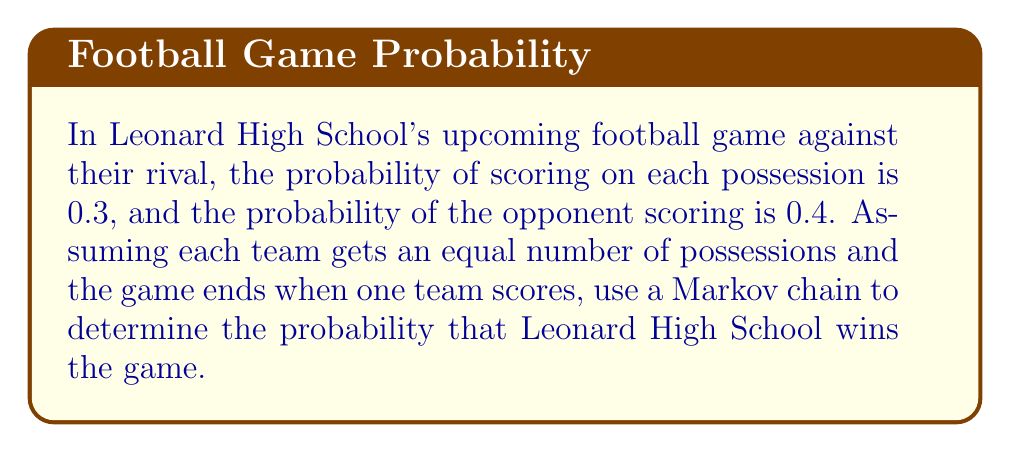Help me with this question. Let's approach this step-by-step using a Markov chain:

1) Define the states:
   State 0: Neither team has scored
   State 1: Leonard High School has scored (win)
   State 2: Opponent has scored (loss)

2) Create the transition matrix P:
   $$P = \begin{bmatrix}
   0.3 & 0.3 & 0.4 \\
   0 & 1 & 0 \\
   0 & 0 & 1
   \end{bmatrix}$$

3) States 1 and 2 are absorbing states. We want to find the probability of reaching state 1 before state 2.

4) Let $f_0$ be the probability of Leonard High School winning when starting from state 0. We can write:

   $f_0 = 0.3 \cdot 1 + 0.3 \cdot f_0 + 0.4 \cdot 0$

5) Solve this equation:
   $f_0 = 0.3 + 0.3f_0$
   $0.7f_0 = 0.3$
   $f_0 = \frac{0.3}{0.7} = \frac{3}{7} \approx 0.4286$

Therefore, the probability of Leonard High School winning the game is $\frac{3}{7}$ or approximately 0.4286 or 42.86%.
Answer: $\frac{3}{7}$ 